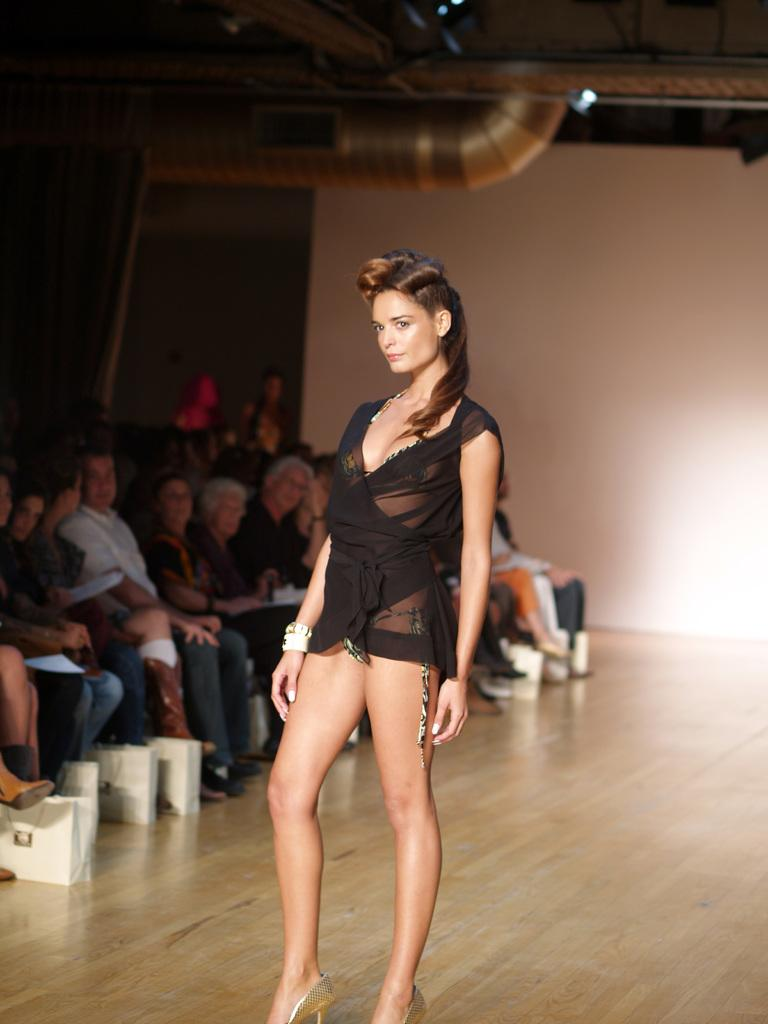What is the main subject of the image? There is a girl standing in the image. What are the other people in the image doing? There are people sitting in the image. What can be seen in the background of the image? There is a wall visible in the background of the image. What is the price of the headphones the girl's mom is wearing in the image? There is no mention of headphones or the girl's mom in the image, so we cannot determine the price of any headphones. 